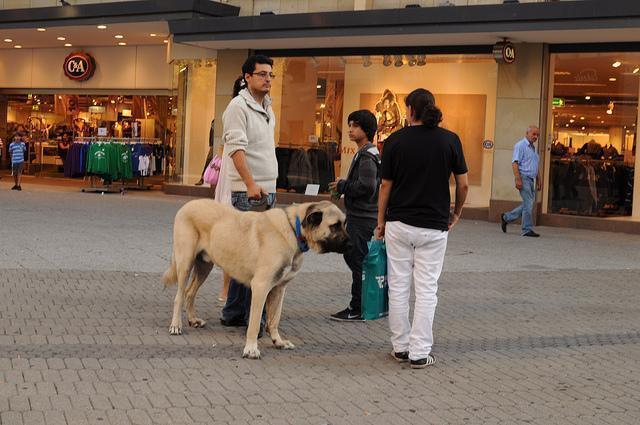What activity are the people shown involved in?
Answer the question by selecting the correct answer among the 4 following choices and explain your choice with a short sentence. The answer should be formatted with the following format: `Answer: choice
Rationale: rationale.`
Options: Shopping, sleeping, dog walking, selling. Answer: shopping.
Rationale: The activity is shopping. 